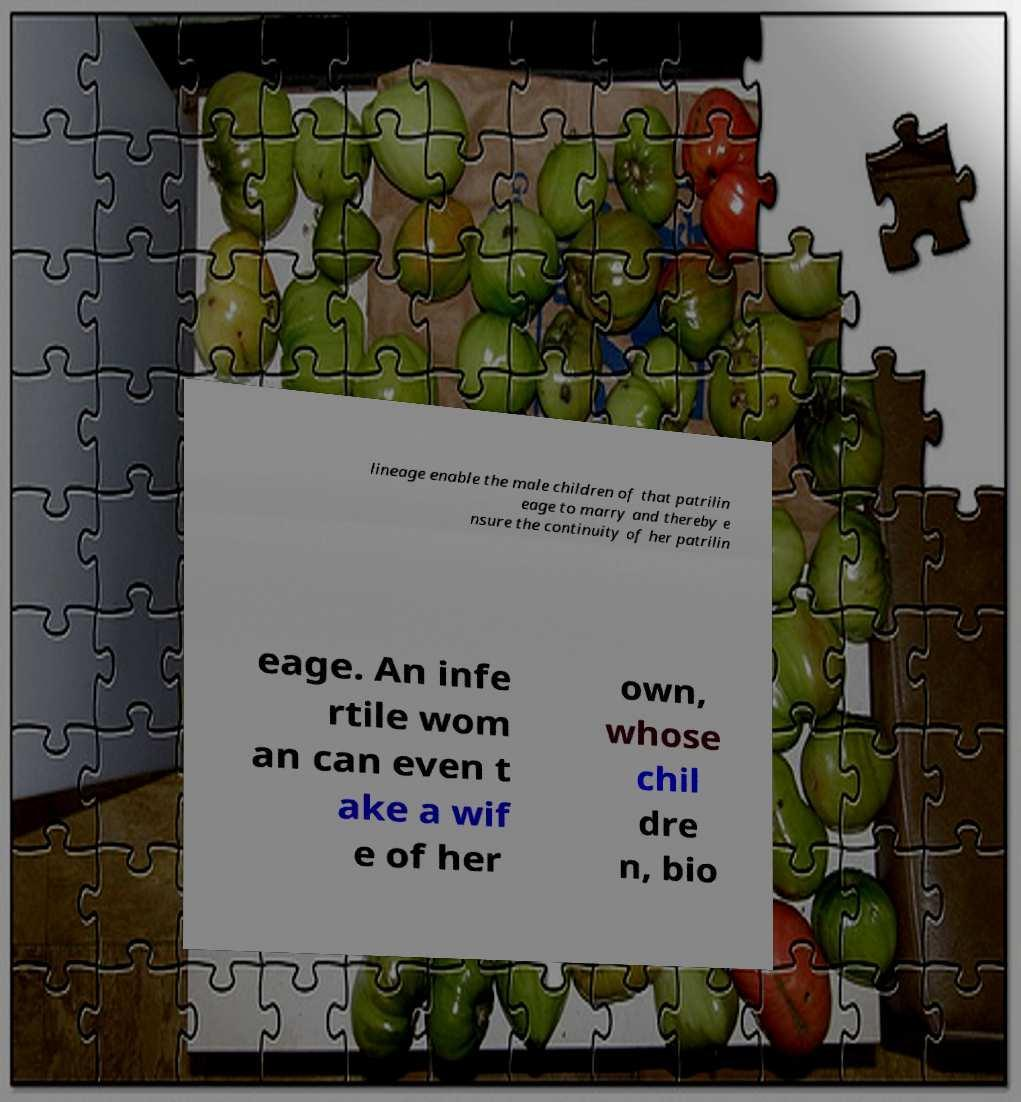Can you accurately transcribe the text from the provided image for me? lineage enable the male children of that patrilin eage to marry and thereby e nsure the continuity of her patrilin eage. An infe rtile wom an can even t ake a wif e of her own, whose chil dre n, bio 